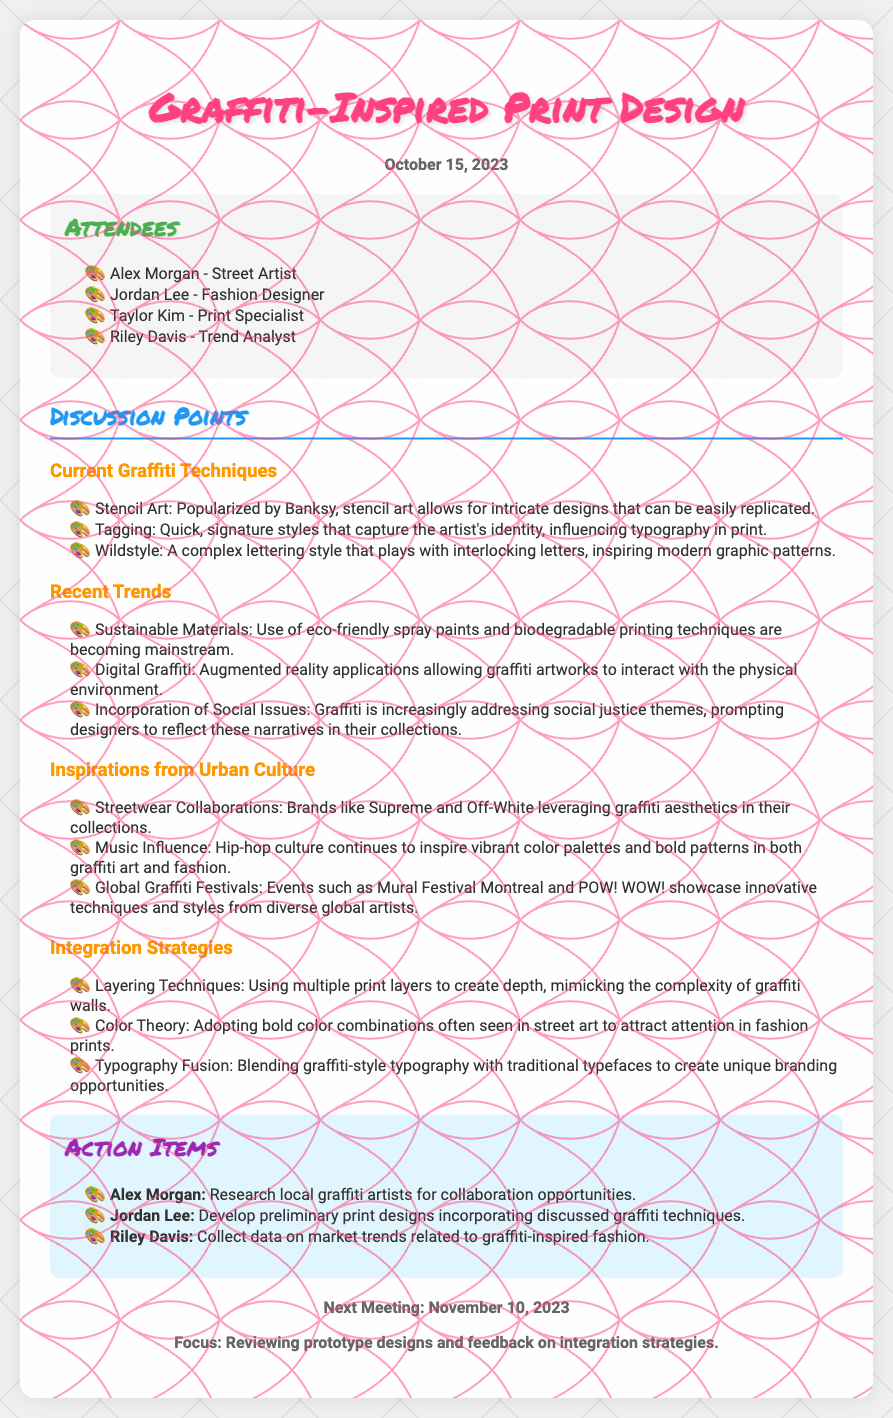What is the date of the meeting? The date of the meeting is mentioned in the header of the document.
Answer: October 15, 2023 Who is the street artist present at the meeting? The list of attendees includes Alex Morgan as the street artist.
Answer: Alex Morgan What technique is popularized by Banksy? The discussion point highlights the technique that Banksy is known for.
Answer: Stencil Art What is a recent trend in graffiti discussed during the meeting? The attendees discussed various recent trends, one of which is mentioned specifically.
Answer: Sustainable Materials What is the next meeting date? The upcoming meeting date is provided toward the end of the document.
Answer: November 10, 2023 Which action item involves research? The action items section lists tasks assigned to each attendee, including research tasks.
Answer: Research local graffiti artists Which graffiti style influences typography in print? The discussion mentions a quick style that captures the artist's identity.
Answer: Tagging What is one method for integrating graffiti into print designs? The participants discussed multiple strategies for using graffiti elements in designs.
Answer: Layering Techniques Who is responsible for developing preliminary print designs? The action items specify who is tasked with this responsibility.
Answer: Jordan Lee 